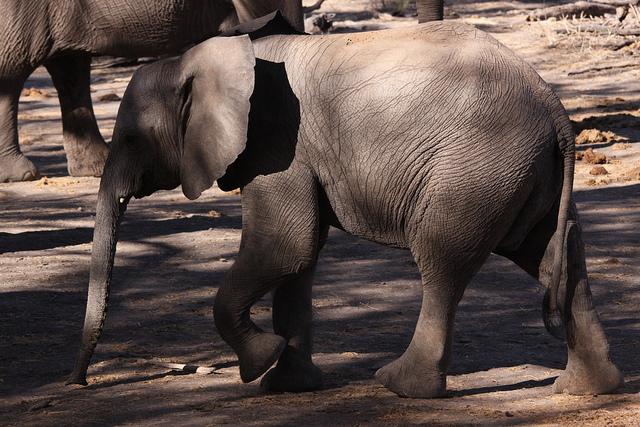What are the elephants doing?
Answer briefly. Walking. Is this a baby elephant?
Write a very short answer. Yes. Where do you think the elephant is?
Answer briefly. Zoo. 